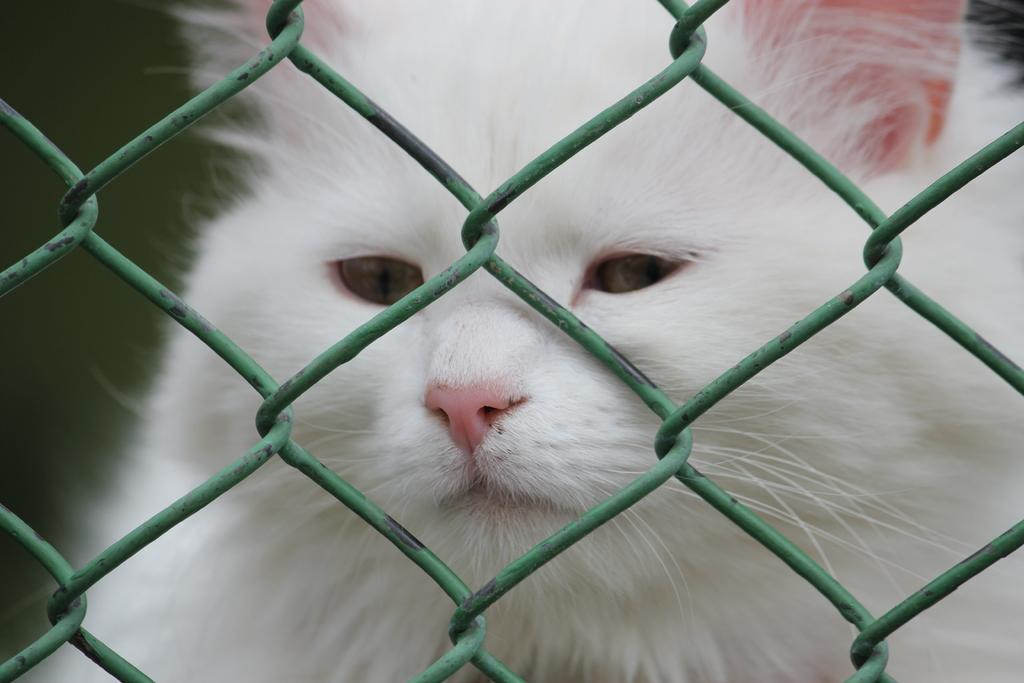What is located in the middle of the image? There is a mesh in the middle of the image. What can be seen through the mesh? A cat is visible through the mesh. What is the color of the cat? The cat is white in color. Who is the creator of the throne in the image? There is no throne present in the image, so it is not possible to determine the creator. 